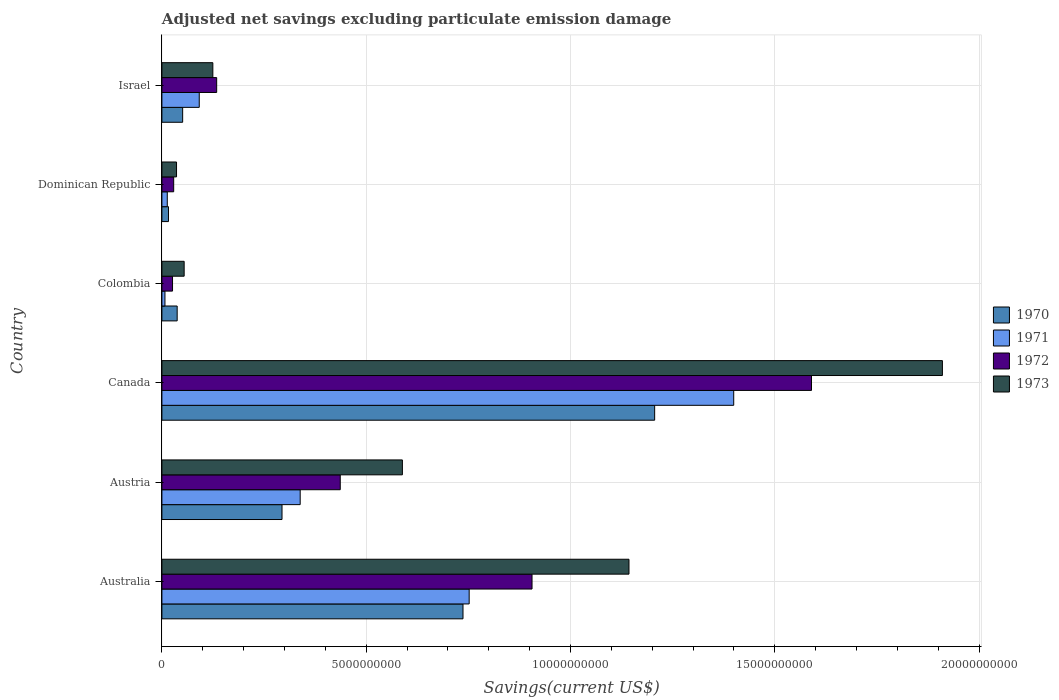Are the number of bars on each tick of the Y-axis equal?
Your response must be concise. Yes. How many bars are there on the 3rd tick from the bottom?
Offer a terse response. 4. What is the adjusted net savings in 1972 in Colombia?
Offer a very short reply. 2.60e+08. Across all countries, what is the maximum adjusted net savings in 1973?
Keep it short and to the point. 1.91e+1. Across all countries, what is the minimum adjusted net savings in 1973?
Provide a succinct answer. 3.58e+08. In which country was the adjusted net savings in 1971 maximum?
Your answer should be compact. Canada. In which country was the adjusted net savings in 1970 minimum?
Your answer should be compact. Dominican Republic. What is the total adjusted net savings in 1971 in the graph?
Provide a succinct answer. 2.60e+1. What is the difference between the adjusted net savings in 1971 in Australia and that in Austria?
Offer a terse response. 4.14e+09. What is the difference between the adjusted net savings in 1972 in Australia and the adjusted net savings in 1971 in Israel?
Your answer should be very brief. 8.15e+09. What is the average adjusted net savings in 1972 per country?
Provide a succinct answer. 5.20e+09. What is the difference between the adjusted net savings in 1973 and adjusted net savings in 1972 in Dominican Republic?
Keep it short and to the point. 6.95e+07. In how many countries, is the adjusted net savings in 1973 greater than 14000000000 US$?
Ensure brevity in your answer.  1. What is the ratio of the adjusted net savings in 1971 in Canada to that in Dominican Republic?
Your response must be concise. 106.4. Is the difference between the adjusted net savings in 1973 in Australia and Israel greater than the difference between the adjusted net savings in 1972 in Australia and Israel?
Make the answer very short. Yes. What is the difference between the highest and the second highest adjusted net savings in 1973?
Ensure brevity in your answer.  7.67e+09. What is the difference between the highest and the lowest adjusted net savings in 1971?
Make the answer very short. 1.39e+1. Is the sum of the adjusted net savings in 1970 in Austria and Dominican Republic greater than the maximum adjusted net savings in 1972 across all countries?
Provide a succinct answer. No. How many bars are there?
Ensure brevity in your answer.  24. Are all the bars in the graph horizontal?
Your response must be concise. Yes. How many countries are there in the graph?
Your response must be concise. 6. Does the graph contain any zero values?
Keep it short and to the point. No. Where does the legend appear in the graph?
Make the answer very short. Center right. How are the legend labels stacked?
Your answer should be compact. Vertical. What is the title of the graph?
Offer a terse response. Adjusted net savings excluding particulate emission damage. Does "2000" appear as one of the legend labels in the graph?
Your response must be concise. No. What is the label or title of the X-axis?
Give a very brief answer. Savings(current US$). What is the Savings(current US$) of 1970 in Australia?
Provide a succinct answer. 7.37e+09. What is the Savings(current US$) of 1971 in Australia?
Give a very brief answer. 7.52e+09. What is the Savings(current US$) of 1972 in Australia?
Give a very brief answer. 9.06e+09. What is the Savings(current US$) in 1973 in Australia?
Offer a terse response. 1.14e+1. What is the Savings(current US$) of 1970 in Austria?
Offer a terse response. 2.94e+09. What is the Savings(current US$) of 1971 in Austria?
Make the answer very short. 3.38e+09. What is the Savings(current US$) in 1972 in Austria?
Ensure brevity in your answer.  4.37e+09. What is the Savings(current US$) of 1973 in Austria?
Your response must be concise. 5.89e+09. What is the Savings(current US$) of 1970 in Canada?
Provide a succinct answer. 1.21e+1. What is the Savings(current US$) in 1971 in Canada?
Offer a very short reply. 1.40e+1. What is the Savings(current US$) in 1972 in Canada?
Keep it short and to the point. 1.59e+1. What is the Savings(current US$) in 1973 in Canada?
Your answer should be compact. 1.91e+1. What is the Savings(current US$) in 1970 in Colombia?
Give a very brief answer. 3.74e+08. What is the Savings(current US$) of 1971 in Colombia?
Ensure brevity in your answer.  7.46e+07. What is the Savings(current US$) of 1972 in Colombia?
Keep it short and to the point. 2.60e+08. What is the Savings(current US$) in 1973 in Colombia?
Provide a succinct answer. 5.45e+08. What is the Savings(current US$) in 1970 in Dominican Republic?
Keep it short and to the point. 1.61e+08. What is the Savings(current US$) in 1971 in Dominican Republic?
Your response must be concise. 1.32e+08. What is the Savings(current US$) in 1972 in Dominican Republic?
Ensure brevity in your answer.  2.89e+08. What is the Savings(current US$) of 1973 in Dominican Republic?
Provide a short and direct response. 3.58e+08. What is the Savings(current US$) in 1970 in Israel?
Offer a terse response. 5.08e+08. What is the Savings(current US$) of 1971 in Israel?
Make the answer very short. 9.14e+08. What is the Savings(current US$) in 1972 in Israel?
Provide a short and direct response. 1.34e+09. What is the Savings(current US$) in 1973 in Israel?
Keep it short and to the point. 1.25e+09. Across all countries, what is the maximum Savings(current US$) in 1970?
Make the answer very short. 1.21e+1. Across all countries, what is the maximum Savings(current US$) of 1971?
Provide a succinct answer. 1.40e+1. Across all countries, what is the maximum Savings(current US$) of 1972?
Keep it short and to the point. 1.59e+1. Across all countries, what is the maximum Savings(current US$) in 1973?
Provide a succinct answer. 1.91e+1. Across all countries, what is the minimum Savings(current US$) in 1970?
Keep it short and to the point. 1.61e+08. Across all countries, what is the minimum Savings(current US$) in 1971?
Provide a succinct answer. 7.46e+07. Across all countries, what is the minimum Savings(current US$) in 1972?
Provide a succinct answer. 2.60e+08. Across all countries, what is the minimum Savings(current US$) in 1973?
Your answer should be very brief. 3.58e+08. What is the total Savings(current US$) in 1970 in the graph?
Your response must be concise. 2.34e+1. What is the total Savings(current US$) of 1971 in the graph?
Your answer should be compact. 2.60e+1. What is the total Savings(current US$) of 1972 in the graph?
Make the answer very short. 3.12e+1. What is the total Savings(current US$) of 1973 in the graph?
Keep it short and to the point. 3.86e+1. What is the difference between the Savings(current US$) in 1970 in Australia and that in Austria?
Provide a short and direct response. 4.43e+09. What is the difference between the Savings(current US$) of 1971 in Australia and that in Austria?
Your answer should be compact. 4.14e+09. What is the difference between the Savings(current US$) of 1972 in Australia and that in Austria?
Offer a terse response. 4.69e+09. What is the difference between the Savings(current US$) of 1973 in Australia and that in Austria?
Provide a short and direct response. 5.55e+09. What is the difference between the Savings(current US$) of 1970 in Australia and that in Canada?
Your answer should be very brief. -4.69e+09. What is the difference between the Savings(current US$) of 1971 in Australia and that in Canada?
Make the answer very short. -6.48e+09. What is the difference between the Savings(current US$) of 1972 in Australia and that in Canada?
Make the answer very short. -6.84e+09. What is the difference between the Savings(current US$) in 1973 in Australia and that in Canada?
Make the answer very short. -7.67e+09. What is the difference between the Savings(current US$) in 1970 in Australia and that in Colombia?
Ensure brevity in your answer.  7.00e+09. What is the difference between the Savings(current US$) in 1971 in Australia and that in Colombia?
Your answer should be compact. 7.45e+09. What is the difference between the Savings(current US$) of 1972 in Australia and that in Colombia?
Ensure brevity in your answer.  8.80e+09. What is the difference between the Savings(current US$) in 1973 in Australia and that in Colombia?
Provide a short and direct response. 1.09e+1. What is the difference between the Savings(current US$) of 1970 in Australia and that in Dominican Republic?
Offer a terse response. 7.21e+09. What is the difference between the Savings(current US$) of 1971 in Australia and that in Dominican Republic?
Provide a succinct answer. 7.39e+09. What is the difference between the Savings(current US$) of 1972 in Australia and that in Dominican Republic?
Keep it short and to the point. 8.77e+09. What is the difference between the Savings(current US$) in 1973 in Australia and that in Dominican Republic?
Make the answer very short. 1.11e+1. What is the difference between the Savings(current US$) of 1970 in Australia and that in Israel?
Ensure brevity in your answer.  6.86e+09. What is the difference between the Savings(current US$) in 1971 in Australia and that in Israel?
Ensure brevity in your answer.  6.61e+09. What is the difference between the Savings(current US$) of 1972 in Australia and that in Israel?
Offer a terse response. 7.72e+09. What is the difference between the Savings(current US$) of 1973 in Australia and that in Israel?
Give a very brief answer. 1.02e+1. What is the difference between the Savings(current US$) of 1970 in Austria and that in Canada?
Your answer should be compact. -9.12e+09. What is the difference between the Savings(current US$) of 1971 in Austria and that in Canada?
Make the answer very short. -1.06e+1. What is the difference between the Savings(current US$) of 1972 in Austria and that in Canada?
Make the answer very short. -1.15e+1. What is the difference between the Savings(current US$) in 1973 in Austria and that in Canada?
Provide a short and direct response. -1.32e+1. What is the difference between the Savings(current US$) of 1970 in Austria and that in Colombia?
Offer a terse response. 2.57e+09. What is the difference between the Savings(current US$) in 1971 in Austria and that in Colombia?
Give a very brief answer. 3.31e+09. What is the difference between the Savings(current US$) of 1972 in Austria and that in Colombia?
Your answer should be compact. 4.11e+09. What is the difference between the Savings(current US$) in 1973 in Austria and that in Colombia?
Keep it short and to the point. 5.34e+09. What is the difference between the Savings(current US$) of 1970 in Austria and that in Dominican Republic?
Make the answer very short. 2.78e+09. What is the difference between the Savings(current US$) of 1971 in Austria and that in Dominican Republic?
Provide a short and direct response. 3.25e+09. What is the difference between the Savings(current US$) in 1972 in Austria and that in Dominican Republic?
Your answer should be very brief. 4.08e+09. What is the difference between the Savings(current US$) in 1973 in Austria and that in Dominican Republic?
Provide a succinct answer. 5.53e+09. What is the difference between the Savings(current US$) of 1970 in Austria and that in Israel?
Give a very brief answer. 2.43e+09. What is the difference between the Savings(current US$) in 1971 in Austria and that in Israel?
Offer a terse response. 2.47e+09. What is the difference between the Savings(current US$) in 1972 in Austria and that in Israel?
Give a very brief answer. 3.02e+09. What is the difference between the Savings(current US$) of 1973 in Austria and that in Israel?
Offer a very short reply. 4.64e+09. What is the difference between the Savings(current US$) of 1970 in Canada and that in Colombia?
Give a very brief answer. 1.17e+1. What is the difference between the Savings(current US$) of 1971 in Canada and that in Colombia?
Offer a very short reply. 1.39e+1. What is the difference between the Savings(current US$) of 1972 in Canada and that in Colombia?
Ensure brevity in your answer.  1.56e+1. What is the difference between the Savings(current US$) in 1973 in Canada and that in Colombia?
Your response must be concise. 1.86e+1. What is the difference between the Savings(current US$) in 1970 in Canada and that in Dominican Republic?
Provide a succinct answer. 1.19e+1. What is the difference between the Savings(current US$) in 1971 in Canada and that in Dominican Republic?
Keep it short and to the point. 1.39e+1. What is the difference between the Savings(current US$) in 1972 in Canada and that in Dominican Republic?
Provide a succinct answer. 1.56e+1. What is the difference between the Savings(current US$) in 1973 in Canada and that in Dominican Republic?
Offer a very short reply. 1.87e+1. What is the difference between the Savings(current US$) in 1970 in Canada and that in Israel?
Ensure brevity in your answer.  1.16e+1. What is the difference between the Savings(current US$) of 1971 in Canada and that in Israel?
Provide a succinct answer. 1.31e+1. What is the difference between the Savings(current US$) in 1972 in Canada and that in Israel?
Your response must be concise. 1.46e+1. What is the difference between the Savings(current US$) in 1973 in Canada and that in Israel?
Offer a terse response. 1.79e+1. What is the difference between the Savings(current US$) of 1970 in Colombia and that in Dominican Republic?
Offer a terse response. 2.13e+08. What is the difference between the Savings(current US$) of 1971 in Colombia and that in Dominican Republic?
Your answer should be very brief. -5.69e+07. What is the difference between the Savings(current US$) of 1972 in Colombia and that in Dominican Republic?
Ensure brevity in your answer.  -2.84e+07. What is the difference between the Savings(current US$) in 1973 in Colombia and that in Dominican Republic?
Give a very brief answer. 1.87e+08. What is the difference between the Savings(current US$) of 1970 in Colombia and that in Israel?
Make the answer very short. -1.34e+08. What is the difference between the Savings(current US$) of 1971 in Colombia and that in Israel?
Make the answer very short. -8.40e+08. What is the difference between the Savings(current US$) of 1972 in Colombia and that in Israel?
Your answer should be compact. -1.08e+09. What is the difference between the Savings(current US$) of 1973 in Colombia and that in Israel?
Make the answer very short. -7.02e+08. What is the difference between the Savings(current US$) in 1970 in Dominican Republic and that in Israel?
Your response must be concise. -3.47e+08. What is the difference between the Savings(current US$) of 1971 in Dominican Republic and that in Israel?
Keep it short and to the point. -7.83e+08. What is the difference between the Savings(current US$) in 1972 in Dominican Republic and that in Israel?
Make the answer very short. -1.05e+09. What is the difference between the Savings(current US$) in 1973 in Dominican Republic and that in Israel?
Make the answer very short. -8.89e+08. What is the difference between the Savings(current US$) in 1970 in Australia and the Savings(current US$) in 1971 in Austria?
Your answer should be very brief. 3.98e+09. What is the difference between the Savings(current US$) of 1970 in Australia and the Savings(current US$) of 1972 in Austria?
Provide a succinct answer. 3.00e+09. What is the difference between the Savings(current US$) of 1970 in Australia and the Savings(current US$) of 1973 in Austria?
Offer a very short reply. 1.48e+09. What is the difference between the Savings(current US$) of 1971 in Australia and the Savings(current US$) of 1972 in Austria?
Provide a succinct answer. 3.16e+09. What is the difference between the Savings(current US$) in 1971 in Australia and the Savings(current US$) in 1973 in Austria?
Your answer should be compact. 1.63e+09. What is the difference between the Savings(current US$) of 1972 in Australia and the Savings(current US$) of 1973 in Austria?
Make the answer very short. 3.17e+09. What is the difference between the Savings(current US$) in 1970 in Australia and the Savings(current US$) in 1971 in Canada?
Offer a terse response. -6.63e+09. What is the difference between the Savings(current US$) in 1970 in Australia and the Savings(current US$) in 1972 in Canada?
Give a very brief answer. -8.53e+09. What is the difference between the Savings(current US$) of 1970 in Australia and the Savings(current US$) of 1973 in Canada?
Provide a short and direct response. -1.17e+1. What is the difference between the Savings(current US$) of 1971 in Australia and the Savings(current US$) of 1972 in Canada?
Your answer should be very brief. -8.38e+09. What is the difference between the Savings(current US$) of 1971 in Australia and the Savings(current US$) of 1973 in Canada?
Give a very brief answer. -1.16e+1. What is the difference between the Savings(current US$) in 1972 in Australia and the Savings(current US$) in 1973 in Canada?
Provide a short and direct response. -1.00e+1. What is the difference between the Savings(current US$) of 1970 in Australia and the Savings(current US$) of 1971 in Colombia?
Offer a terse response. 7.30e+09. What is the difference between the Savings(current US$) of 1970 in Australia and the Savings(current US$) of 1972 in Colombia?
Keep it short and to the point. 7.11e+09. What is the difference between the Savings(current US$) in 1970 in Australia and the Savings(current US$) in 1973 in Colombia?
Provide a short and direct response. 6.83e+09. What is the difference between the Savings(current US$) in 1971 in Australia and the Savings(current US$) in 1972 in Colombia?
Provide a short and direct response. 7.26e+09. What is the difference between the Savings(current US$) in 1971 in Australia and the Savings(current US$) in 1973 in Colombia?
Provide a short and direct response. 6.98e+09. What is the difference between the Savings(current US$) in 1972 in Australia and the Savings(current US$) in 1973 in Colombia?
Make the answer very short. 8.51e+09. What is the difference between the Savings(current US$) of 1970 in Australia and the Savings(current US$) of 1971 in Dominican Republic?
Give a very brief answer. 7.24e+09. What is the difference between the Savings(current US$) in 1970 in Australia and the Savings(current US$) in 1972 in Dominican Republic?
Provide a short and direct response. 7.08e+09. What is the difference between the Savings(current US$) in 1970 in Australia and the Savings(current US$) in 1973 in Dominican Republic?
Your answer should be compact. 7.01e+09. What is the difference between the Savings(current US$) in 1971 in Australia and the Savings(current US$) in 1972 in Dominican Republic?
Give a very brief answer. 7.23e+09. What is the difference between the Savings(current US$) in 1971 in Australia and the Savings(current US$) in 1973 in Dominican Republic?
Provide a short and direct response. 7.16e+09. What is the difference between the Savings(current US$) in 1972 in Australia and the Savings(current US$) in 1973 in Dominican Republic?
Keep it short and to the point. 8.70e+09. What is the difference between the Savings(current US$) in 1970 in Australia and the Savings(current US$) in 1971 in Israel?
Provide a short and direct response. 6.46e+09. What is the difference between the Savings(current US$) in 1970 in Australia and the Savings(current US$) in 1972 in Israel?
Provide a succinct answer. 6.03e+09. What is the difference between the Savings(current US$) of 1970 in Australia and the Savings(current US$) of 1973 in Israel?
Your response must be concise. 6.12e+09. What is the difference between the Savings(current US$) in 1971 in Australia and the Savings(current US$) in 1972 in Israel?
Provide a short and direct response. 6.18e+09. What is the difference between the Savings(current US$) of 1971 in Australia and the Savings(current US$) of 1973 in Israel?
Provide a short and direct response. 6.27e+09. What is the difference between the Savings(current US$) of 1972 in Australia and the Savings(current US$) of 1973 in Israel?
Ensure brevity in your answer.  7.81e+09. What is the difference between the Savings(current US$) of 1970 in Austria and the Savings(current US$) of 1971 in Canada?
Your answer should be very brief. -1.11e+1. What is the difference between the Savings(current US$) of 1970 in Austria and the Savings(current US$) of 1972 in Canada?
Offer a very short reply. -1.30e+1. What is the difference between the Savings(current US$) in 1970 in Austria and the Savings(current US$) in 1973 in Canada?
Offer a very short reply. -1.62e+1. What is the difference between the Savings(current US$) of 1971 in Austria and the Savings(current US$) of 1972 in Canada?
Your answer should be very brief. -1.25e+1. What is the difference between the Savings(current US$) of 1971 in Austria and the Savings(current US$) of 1973 in Canada?
Give a very brief answer. -1.57e+1. What is the difference between the Savings(current US$) in 1972 in Austria and the Savings(current US$) in 1973 in Canada?
Give a very brief answer. -1.47e+1. What is the difference between the Savings(current US$) in 1970 in Austria and the Savings(current US$) in 1971 in Colombia?
Provide a short and direct response. 2.87e+09. What is the difference between the Savings(current US$) in 1970 in Austria and the Savings(current US$) in 1972 in Colombia?
Keep it short and to the point. 2.68e+09. What is the difference between the Savings(current US$) in 1970 in Austria and the Savings(current US$) in 1973 in Colombia?
Your response must be concise. 2.40e+09. What is the difference between the Savings(current US$) in 1971 in Austria and the Savings(current US$) in 1972 in Colombia?
Your response must be concise. 3.12e+09. What is the difference between the Savings(current US$) in 1971 in Austria and the Savings(current US$) in 1973 in Colombia?
Your answer should be very brief. 2.84e+09. What is the difference between the Savings(current US$) of 1972 in Austria and the Savings(current US$) of 1973 in Colombia?
Your answer should be very brief. 3.82e+09. What is the difference between the Savings(current US$) of 1970 in Austria and the Savings(current US$) of 1971 in Dominican Republic?
Your answer should be very brief. 2.81e+09. What is the difference between the Savings(current US$) of 1970 in Austria and the Savings(current US$) of 1972 in Dominican Republic?
Make the answer very short. 2.65e+09. What is the difference between the Savings(current US$) of 1970 in Austria and the Savings(current US$) of 1973 in Dominican Republic?
Ensure brevity in your answer.  2.58e+09. What is the difference between the Savings(current US$) in 1971 in Austria and the Savings(current US$) in 1972 in Dominican Republic?
Offer a terse response. 3.10e+09. What is the difference between the Savings(current US$) of 1971 in Austria and the Savings(current US$) of 1973 in Dominican Republic?
Ensure brevity in your answer.  3.03e+09. What is the difference between the Savings(current US$) of 1972 in Austria and the Savings(current US$) of 1973 in Dominican Republic?
Keep it short and to the point. 4.01e+09. What is the difference between the Savings(current US$) in 1970 in Austria and the Savings(current US$) in 1971 in Israel?
Your answer should be very brief. 2.03e+09. What is the difference between the Savings(current US$) in 1970 in Austria and the Savings(current US$) in 1972 in Israel?
Ensure brevity in your answer.  1.60e+09. What is the difference between the Savings(current US$) in 1970 in Austria and the Savings(current US$) in 1973 in Israel?
Your answer should be very brief. 1.69e+09. What is the difference between the Savings(current US$) in 1971 in Austria and the Savings(current US$) in 1972 in Israel?
Provide a short and direct response. 2.04e+09. What is the difference between the Savings(current US$) in 1971 in Austria and the Savings(current US$) in 1973 in Israel?
Your answer should be compact. 2.14e+09. What is the difference between the Savings(current US$) of 1972 in Austria and the Savings(current US$) of 1973 in Israel?
Give a very brief answer. 3.12e+09. What is the difference between the Savings(current US$) of 1970 in Canada and the Savings(current US$) of 1971 in Colombia?
Give a very brief answer. 1.20e+1. What is the difference between the Savings(current US$) of 1970 in Canada and the Savings(current US$) of 1972 in Colombia?
Provide a succinct answer. 1.18e+1. What is the difference between the Savings(current US$) in 1970 in Canada and the Savings(current US$) in 1973 in Colombia?
Provide a succinct answer. 1.15e+1. What is the difference between the Savings(current US$) of 1971 in Canada and the Savings(current US$) of 1972 in Colombia?
Keep it short and to the point. 1.37e+1. What is the difference between the Savings(current US$) of 1971 in Canada and the Savings(current US$) of 1973 in Colombia?
Give a very brief answer. 1.35e+1. What is the difference between the Savings(current US$) in 1972 in Canada and the Savings(current US$) in 1973 in Colombia?
Your response must be concise. 1.54e+1. What is the difference between the Savings(current US$) in 1970 in Canada and the Savings(current US$) in 1971 in Dominican Republic?
Your response must be concise. 1.19e+1. What is the difference between the Savings(current US$) of 1970 in Canada and the Savings(current US$) of 1972 in Dominican Republic?
Offer a terse response. 1.18e+1. What is the difference between the Savings(current US$) in 1970 in Canada and the Savings(current US$) in 1973 in Dominican Republic?
Provide a short and direct response. 1.17e+1. What is the difference between the Savings(current US$) of 1971 in Canada and the Savings(current US$) of 1972 in Dominican Republic?
Ensure brevity in your answer.  1.37e+1. What is the difference between the Savings(current US$) of 1971 in Canada and the Savings(current US$) of 1973 in Dominican Republic?
Your answer should be very brief. 1.36e+1. What is the difference between the Savings(current US$) of 1972 in Canada and the Savings(current US$) of 1973 in Dominican Republic?
Your answer should be compact. 1.55e+1. What is the difference between the Savings(current US$) of 1970 in Canada and the Savings(current US$) of 1971 in Israel?
Provide a succinct answer. 1.11e+1. What is the difference between the Savings(current US$) in 1970 in Canada and the Savings(current US$) in 1972 in Israel?
Your answer should be very brief. 1.07e+1. What is the difference between the Savings(current US$) of 1970 in Canada and the Savings(current US$) of 1973 in Israel?
Give a very brief answer. 1.08e+1. What is the difference between the Savings(current US$) in 1971 in Canada and the Savings(current US$) in 1972 in Israel?
Give a very brief answer. 1.27e+1. What is the difference between the Savings(current US$) in 1971 in Canada and the Savings(current US$) in 1973 in Israel?
Offer a terse response. 1.27e+1. What is the difference between the Savings(current US$) in 1972 in Canada and the Savings(current US$) in 1973 in Israel?
Your response must be concise. 1.47e+1. What is the difference between the Savings(current US$) in 1970 in Colombia and the Savings(current US$) in 1971 in Dominican Republic?
Your answer should be very brief. 2.42e+08. What is the difference between the Savings(current US$) of 1970 in Colombia and the Savings(current US$) of 1972 in Dominican Republic?
Offer a terse response. 8.52e+07. What is the difference between the Savings(current US$) of 1970 in Colombia and the Savings(current US$) of 1973 in Dominican Republic?
Your answer should be very brief. 1.57e+07. What is the difference between the Savings(current US$) in 1971 in Colombia and the Savings(current US$) in 1972 in Dominican Republic?
Provide a short and direct response. -2.14e+08. What is the difference between the Savings(current US$) of 1971 in Colombia and the Savings(current US$) of 1973 in Dominican Republic?
Provide a succinct answer. -2.84e+08. What is the difference between the Savings(current US$) of 1972 in Colombia and the Savings(current US$) of 1973 in Dominican Republic?
Give a very brief answer. -9.79e+07. What is the difference between the Savings(current US$) in 1970 in Colombia and the Savings(current US$) in 1971 in Israel?
Make the answer very short. -5.40e+08. What is the difference between the Savings(current US$) of 1970 in Colombia and the Savings(current US$) of 1972 in Israel?
Ensure brevity in your answer.  -9.67e+08. What is the difference between the Savings(current US$) in 1970 in Colombia and the Savings(current US$) in 1973 in Israel?
Offer a very short reply. -8.73e+08. What is the difference between the Savings(current US$) of 1971 in Colombia and the Savings(current US$) of 1972 in Israel?
Your answer should be very brief. -1.27e+09. What is the difference between the Savings(current US$) in 1971 in Colombia and the Savings(current US$) in 1973 in Israel?
Offer a terse response. -1.17e+09. What is the difference between the Savings(current US$) of 1972 in Colombia and the Savings(current US$) of 1973 in Israel?
Your response must be concise. -9.87e+08. What is the difference between the Savings(current US$) in 1970 in Dominican Republic and the Savings(current US$) in 1971 in Israel?
Keep it short and to the point. -7.53e+08. What is the difference between the Savings(current US$) in 1970 in Dominican Republic and the Savings(current US$) in 1972 in Israel?
Ensure brevity in your answer.  -1.18e+09. What is the difference between the Savings(current US$) in 1970 in Dominican Republic and the Savings(current US$) in 1973 in Israel?
Offer a terse response. -1.09e+09. What is the difference between the Savings(current US$) in 1971 in Dominican Republic and the Savings(current US$) in 1972 in Israel?
Provide a succinct answer. -1.21e+09. What is the difference between the Savings(current US$) in 1971 in Dominican Republic and the Savings(current US$) in 1973 in Israel?
Provide a short and direct response. -1.12e+09. What is the difference between the Savings(current US$) in 1972 in Dominican Republic and the Savings(current US$) in 1973 in Israel?
Make the answer very short. -9.58e+08. What is the average Savings(current US$) of 1970 per country?
Offer a very short reply. 3.90e+09. What is the average Savings(current US$) in 1971 per country?
Make the answer very short. 4.34e+09. What is the average Savings(current US$) of 1972 per country?
Offer a terse response. 5.20e+09. What is the average Savings(current US$) of 1973 per country?
Provide a succinct answer. 6.43e+09. What is the difference between the Savings(current US$) in 1970 and Savings(current US$) in 1971 in Australia?
Ensure brevity in your answer.  -1.51e+08. What is the difference between the Savings(current US$) of 1970 and Savings(current US$) of 1972 in Australia?
Ensure brevity in your answer.  -1.69e+09. What is the difference between the Savings(current US$) in 1970 and Savings(current US$) in 1973 in Australia?
Your answer should be compact. -4.06e+09. What is the difference between the Savings(current US$) in 1971 and Savings(current US$) in 1972 in Australia?
Offer a terse response. -1.54e+09. What is the difference between the Savings(current US$) in 1971 and Savings(current US$) in 1973 in Australia?
Your response must be concise. -3.91e+09. What is the difference between the Savings(current US$) of 1972 and Savings(current US$) of 1973 in Australia?
Ensure brevity in your answer.  -2.37e+09. What is the difference between the Savings(current US$) in 1970 and Savings(current US$) in 1971 in Austria?
Your response must be concise. -4.45e+08. What is the difference between the Savings(current US$) in 1970 and Savings(current US$) in 1972 in Austria?
Your answer should be very brief. -1.43e+09. What is the difference between the Savings(current US$) in 1970 and Savings(current US$) in 1973 in Austria?
Ensure brevity in your answer.  -2.95e+09. What is the difference between the Savings(current US$) in 1971 and Savings(current US$) in 1972 in Austria?
Ensure brevity in your answer.  -9.81e+08. What is the difference between the Savings(current US$) in 1971 and Savings(current US$) in 1973 in Austria?
Provide a succinct answer. -2.50e+09. What is the difference between the Savings(current US$) of 1972 and Savings(current US$) of 1973 in Austria?
Give a very brief answer. -1.52e+09. What is the difference between the Savings(current US$) of 1970 and Savings(current US$) of 1971 in Canada?
Keep it short and to the point. -1.94e+09. What is the difference between the Savings(current US$) in 1970 and Savings(current US$) in 1972 in Canada?
Make the answer very short. -3.84e+09. What is the difference between the Savings(current US$) of 1970 and Savings(current US$) of 1973 in Canada?
Provide a short and direct response. -7.04e+09. What is the difference between the Savings(current US$) in 1971 and Savings(current US$) in 1972 in Canada?
Offer a terse response. -1.90e+09. What is the difference between the Savings(current US$) in 1971 and Savings(current US$) in 1973 in Canada?
Offer a very short reply. -5.11e+09. What is the difference between the Savings(current US$) of 1972 and Savings(current US$) of 1973 in Canada?
Provide a succinct answer. -3.20e+09. What is the difference between the Savings(current US$) of 1970 and Savings(current US$) of 1971 in Colombia?
Your response must be concise. 2.99e+08. What is the difference between the Savings(current US$) in 1970 and Savings(current US$) in 1972 in Colombia?
Provide a succinct answer. 1.14e+08. What is the difference between the Savings(current US$) in 1970 and Savings(current US$) in 1973 in Colombia?
Your answer should be very brief. -1.71e+08. What is the difference between the Savings(current US$) of 1971 and Savings(current US$) of 1972 in Colombia?
Offer a terse response. -1.86e+08. What is the difference between the Savings(current US$) of 1971 and Savings(current US$) of 1973 in Colombia?
Your response must be concise. -4.70e+08. What is the difference between the Savings(current US$) in 1972 and Savings(current US$) in 1973 in Colombia?
Your answer should be compact. -2.85e+08. What is the difference between the Savings(current US$) of 1970 and Savings(current US$) of 1971 in Dominican Republic?
Your answer should be very brief. 2.96e+07. What is the difference between the Savings(current US$) in 1970 and Savings(current US$) in 1972 in Dominican Republic?
Your response must be concise. -1.28e+08. What is the difference between the Savings(current US$) of 1970 and Savings(current US$) of 1973 in Dominican Republic?
Your answer should be very brief. -1.97e+08. What is the difference between the Savings(current US$) of 1971 and Savings(current US$) of 1972 in Dominican Republic?
Ensure brevity in your answer.  -1.57e+08. What is the difference between the Savings(current US$) of 1971 and Savings(current US$) of 1973 in Dominican Republic?
Your response must be concise. -2.27e+08. What is the difference between the Savings(current US$) of 1972 and Savings(current US$) of 1973 in Dominican Republic?
Your response must be concise. -6.95e+07. What is the difference between the Savings(current US$) of 1970 and Savings(current US$) of 1971 in Israel?
Your answer should be compact. -4.06e+08. What is the difference between the Savings(current US$) in 1970 and Savings(current US$) in 1972 in Israel?
Your answer should be very brief. -8.33e+08. What is the difference between the Savings(current US$) of 1970 and Savings(current US$) of 1973 in Israel?
Your answer should be very brief. -7.39e+08. What is the difference between the Savings(current US$) in 1971 and Savings(current US$) in 1972 in Israel?
Your response must be concise. -4.27e+08. What is the difference between the Savings(current US$) of 1971 and Savings(current US$) of 1973 in Israel?
Give a very brief answer. -3.33e+08. What is the difference between the Savings(current US$) in 1972 and Savings(current US$) in 1973 in Israel?
Offer a terse response. 9.40e+07. What is the ratio of the Savings(current US$) in 1970 in Australia to that in Austria?
Give a very brief answer. 2.51. What is the ratio of the Savings(current US$) in 1971 in Australia to that in Austria?
Provide a short and direct response. 2.22. What is the ratio of the Savings(current US$) in 1972 in Australia to that in Austria?
Offer a very short reply. 2.08. What is the ratio of the Savings(current US$) of 1973 in Australia to that in Austria?
Provide a succinct answer. 1.94. What is the ratio of the Savings(current US$) of 1970 in Australia to that in Canada?
Provide a short and direct response. 0.61. What is the ratio of the Savings(current US$) in 1971 in Australia to that in Canada?
Ensure brevity in your answer.  0.54. What is the ratio of the Savings(current US$) of 1972 in Australia to that in Canada?
Your answer should be very brief. 0.57. What is the ratio of the Savings(current US$) in 1973 in Australia to that in Canada?
Offer a terse response. 0.6. What is the ratio of the Savings(current US$) in 1970 in Australia to that in Colombia?
Your answer should be very brief. 19.71. What is the ratio of the Savings(current US$) in 1971 in Australia to that in Colombia?
Give a very brief answer. 100.8. What is the ratio of the Savings(current US$) in 1972 in Australia to that in Colombia?
Make the answer very short. 34.81. What is the ratio of the Savings(current US$) in 1973 in Australia to that in Colombia?
Make the answer very short. 20.98. What is the ratio of the Savings(current US$) of 1970 in Australia to that in Dominican Republic?
Ensure brevity in your answer.  45.75. What is the ratio of the Savings(current US$) of 1971 in Australia to that in Dominican Republic?
Offer a terse response. 57.18. What is the ratio of the Savings(current US$) in 1972 in Australia to that in Dominican Republic?
Give a very brief answer. 31.38. What is the ratio of the Savings(current US$) in 1973 in Australia to that in Dominican Republic?
Make the answer very short. 31.92. What is the ratio of the Savings(current US$) in 1970 in Australia to that in Israel?
Keep it short and to the point. 14.51. What is the ratio of the Savings(current US$) of 1971 in Australia to that in Israel?
Provide a short and direct response. 8.23. What is the ratio of the Savings(current US$) of 1972 in Australia to that in Israel?
Your answer should be very brief. 6.76. What is the ratio of the Savings(current US$) of 1973 in Australia to that in Israel?
Keep it short and to the point. 9.17. What is the ratio of the Savings(current US$) in 1970 in Austria to that in Canada?
Your answer should be compact. 0.24. What is the ratio of the Savings(current US$) of 1971 in Austria to that in Canada?
Give a very brief answer. 0.24. What is the ratio of the Savings(current US$) in 1972 in Austria to that in Canada?
Give a very brief answer. 0.27. What is the ratio of the Savings(current US$) of 1973 in Austria to that in Canada?
Provide a succinct answer. 0.31. What is the ratio of the Savings(current US$) of 1970 in Austria to that in Colombia?
Your answer should be compact. 7.86. What is the ratio of the Savings(current US$) of 1971 in Austria to that in Colombia?
Offer a very short reply. 45.37. What is the ratio of the Savings(current US$) in 1972 in Austria to that in Colombia?
Give a very brief answer. 16.77. What is the ratio of the Savings(current US$) in 1973 in Austria to that in Colombia?
Your response must be concise. 10.8. What is the ratio of the Savings(current US$) of 1970 in Austria to that in Dominican Republic?
Offer a very short reply. 18.25. What is the ratio of the Savings(current US$) in 1971 in Austria to that in Dominican Republic?
Your answer should be compact. 25.73. What is the ratio of the Savings(current US$) in 1972 in Austria to that in Dominican Republic?
Ensure brevity in your answer.  15.12. What is the ratio of the Savings(current US$) of 1973 in Austria to that in Dominican Republic?
Your answer should be compact. 16.43. What is the ratio of the Savings(current US$) in 1970 in Austria to that in Israel?
Provide a short and direct response. 5.79. What is the ratio of the Savings(current US$) of 1971 in Austria to that in Israel?
Your answer should be very brief. 3.7. What is the ratio of the Savings(current US$) of 1972 in Austria to that in Israel?
Your answer should be very brief. 3.26. What is the ratio of the Savings(current US$) of 1973 in Austria to that in Israel?
Give a very brief answer. 4.72. What is the ratio of the Savings(current US$) of 1970 in Canada to that in Colombia?
Keep it short and to the point. 32.26. What is the ratio of the Savings(current US$) of 1971 in Canada to that in Colombia?
Provide a succinct answer. 187.59. What is the ratio of the Savings(current US$) of 1972 in Canada to that in Colombia?
Keep it short and to the point. 61.09. What is the ratio of the Savings(current US$) of 1973 in Canada to that in Colombia?
Give a very brief answer. 35.07. What is the ratio of the Savings(current US$) of 1970 in Canada to that in Dominican Republic?
Your response must be concise. 74.87. What is the ratio of the Savings(current US$) in 1971 in Canada to that in Dominican Republic?
Provide a succinct answer. 106.4. What is the ratio of the Savings(current US$) in 1972 in Canada to that in Dominican Republic?
Make the answer very short. 55.08. What is the ratio of the Savings(current US$) in 1973 in Canada to that in Dominican Republic?
Your response must be concise. 53.33. What is the ratio of the Savings(current US$) in 1970 in Canada to that in Israel?
Your response must be concise. 23.75. What is the ratio of the Savings(current US$) of 1971 in Canada to that in Israel?
Your answer should be compact. 15.31. What is the ratio of the Savings(current US$) of 1972 in Canada to that in Israel?
Provide a succinct answer. 11.86. What is the ratio of the Savings(current US$) of 1973 in Canada to that in Israel?
Your response must be concise. 15.32. What is the ratio of the Savings(current US$) in 1970 in Colombia to that in Dominican Republic?
Keep it short and to the point. 2.32. What is the ratio of the Savings(current US$) in 1971 in Colombia to that in Dominican Republic?
Make the answer very short. 0.57. What is the ratio of the Savings(current US$) in 1972 in Colombia to that in Dominican Republic?
Ensure brevity in your answer.  0.9. What is the ratio of the Savings(current US$) of 1973 in Colombia to that in Dominican Republic?
Ensure brevity in your answer.  1.52. What is the ratio of the Savings(current US$) in 1970 in Colombia to that in Israel?
Your answer should be compact. 0.74. What is the ratio of the Savings(current US$) of 1971 in Colombia to that in Israel?
Offer a terse response. 0.08. What is the ratio of the Savings(current US$) of 1972 in Colombia to that in Israel?
Give a very brief answer. 0.19. What is the ratio of the Savings(current US$) of 1973 in Colombia to that in Israel?
Ensure brevity in your answer.  0.44. What is the ratio of the Savings(current US$) in 1970 in Dominican Republic to that in Israel?
Keep it short and to the point. 0.32. What is the ratio of the Savings(current US$) in 1971 in Dominican Republic to that in Israel?
Offer a very short reply. 0.14. What is the ratio of the Savings(current US$) in 1972 in Dominican Republic to that in Israel?
Provide a short and direct response. 0.22. What is the ratio of the Savings(current US$) of 1973 in Dominican Republic to that in Israel?
Your response must be concise. 0.29. What is the difference between the highest and the second highest Savings(current US$) of 1970?
Provide a short and direct response. 4.69e+09. What is the difference between the highest and the second highest Savings(current US$) in 1971?
Your answer should be compact. 6.48e+09. What is the difference between the highest and the second highest Savings(current US$) of 1972?
Provide a short and direct response. 6.84e+09. What is the difference between the highest and the second highest Savings(current US$) of 1973?
Provide a succinct answer. 7.67e+09. What is the difference between the highest and the lowest Savings(current US$) of 1970?
Your response must be concise. 1.19e+1. What is the difference between the highest and the lowest Savings(current US$) of 1971?
Provide a short and direct response. 1.39e+1. What is the difference between the highest and the lowest Savings(current US$) in 1972?
Give a very brief answer. 1.56e+1. What is the difference between the highest and the lowest Savings(current US$) of 1973?
Provide a succinct answer. 1.87e+1. 